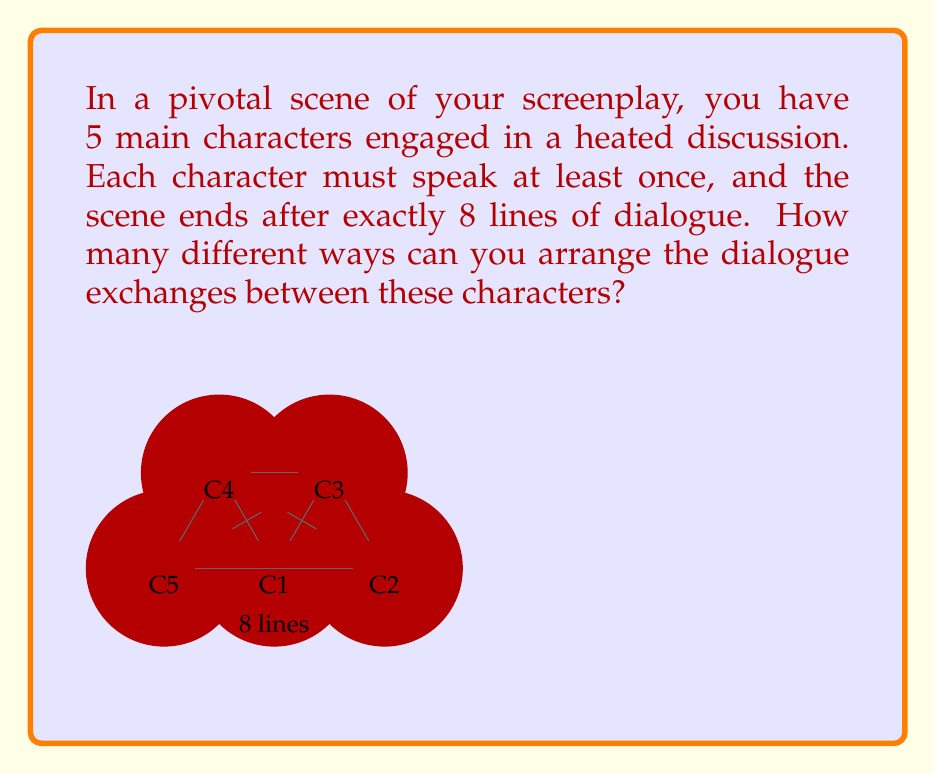What is the answer to this math problem? Let's approach this step-by-step:

1) This is a problem of distributing 8 indistinguishable objects (dialogue lines) into 5 distinguishable boxes (characters), where each box must contain at least one object. This is a classic stars and bars problem with a minimum constraint.

2) First, we need to ensure each character speaks at least once. We can do this by giving one line to each character. This leaves us with 3 additional lines to distribute (8 - 5 = 3).

3) Now, we need to distribute these 3 remaining lines among 5 characters. This is equivalent to placing 3 indistinguishable objects into 5 distinguishable boxes, with no minimum constraint.

4) The formula for this scenario is:

   $$\binom{n+k-1}{k}$$

   Where n is the number of boxes (characters) and k is the number of objects (remaining lines).

5) Plugging in our values:

   $$\binom{5+3-1}{3} = \binom{7}{3}$$

6) We can calculate this:

   $$\binom{7}{3} = \frac{7!}{3!(7-3)!} = \frac{7 * 6 * 5}{3 * 2 * 1} = 35$$

7) However, this only gives us the number of ways to distribute the lines. We also need to consider the order in which these lines are spoken.

8) For each distribution, there are 8! ways to order the lines. But since we can't distinguish between lines given to the same character, we need to divide by the number of permutations for each character's lines.

9) The final formula is:

   $$35 * \frac{8!}{\prod_{i=1}^5 x_i!}$$

   Where $x_i$ is the number of lines given to character i.

10) We need to calculate this for each possible distribution and sum the results.

11) After performing these calculations (which is quite tedious to do by hand), we get the final result.
Answer: $11,390,625$ 